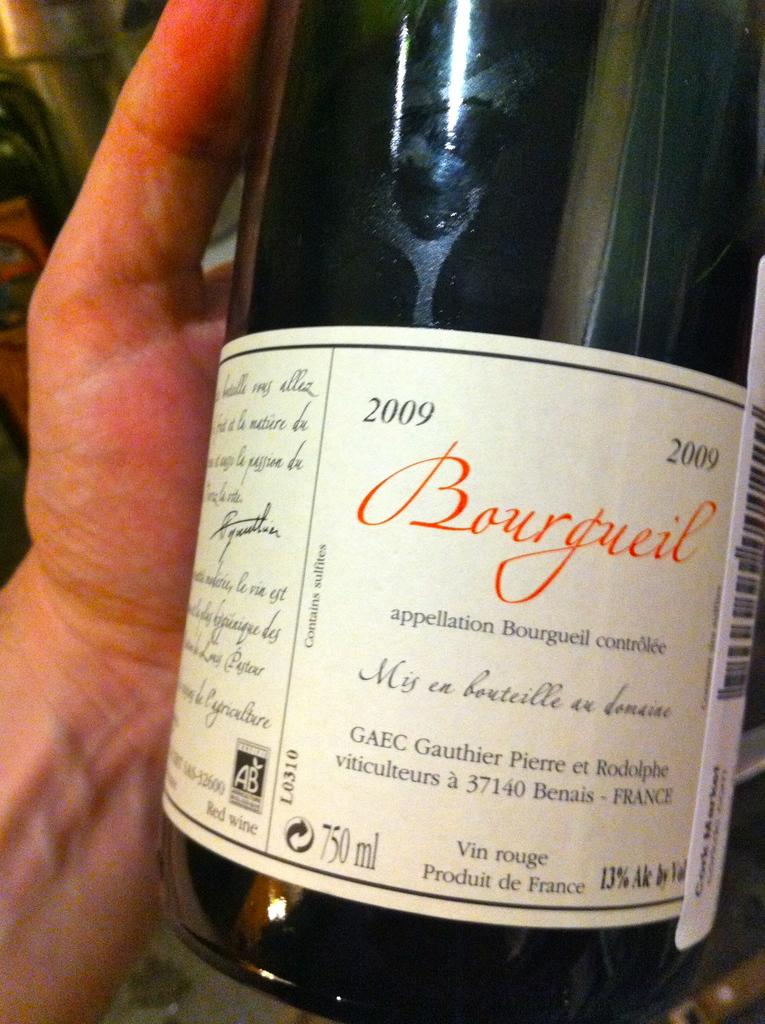<image>
Relay a brief, clear account of the picture shown. A 2009 bottle of wine is labeled with the Bourgueil name. 